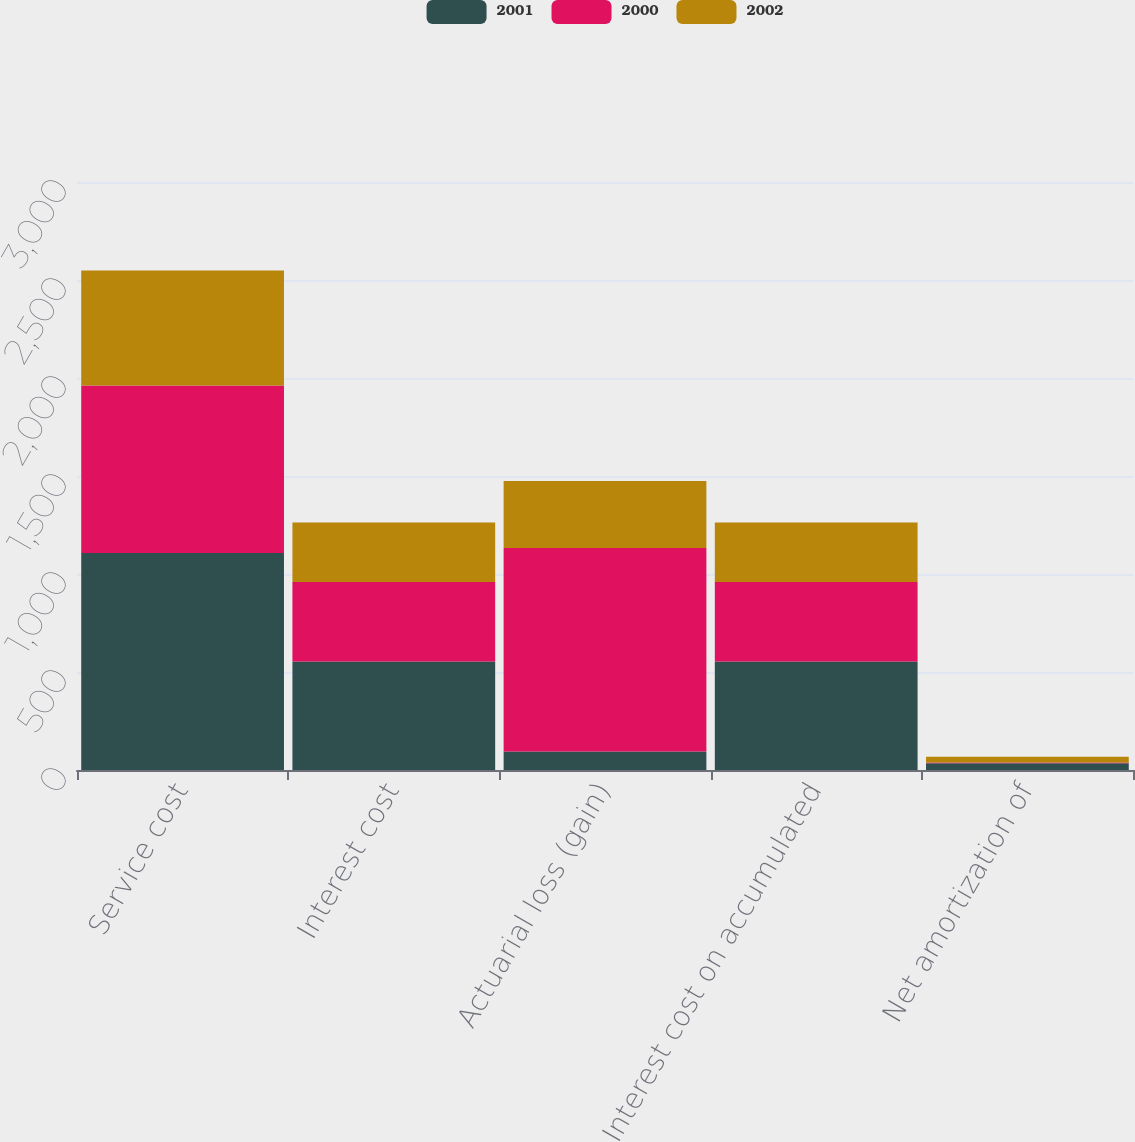<chart> <loc_0><loc_0><loc_500><loc_500><stacked_bar_chart><ecel><fcel>Service cost<fcel>Interest cost<fcel>Actuarial loss (gain)<fcel>Interest cost on accumulated<fcel>Net amortization of<nl><fcel>2001<fcel>1107<fcel>553<fcel>95<fcel>553<fcel>35<nl><fcel>2000<fcel>855<fcel>406<fcel>1038<fcel>406<fcel>3<nl><fcel>2002<fcel>587<fcel>304<fcel>341<fcel>304<fcel>29<nl></chart> 